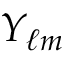<formula> <loc_0><loc_0><loc_500><loc_500>Y _ { \ell m }</formula> 